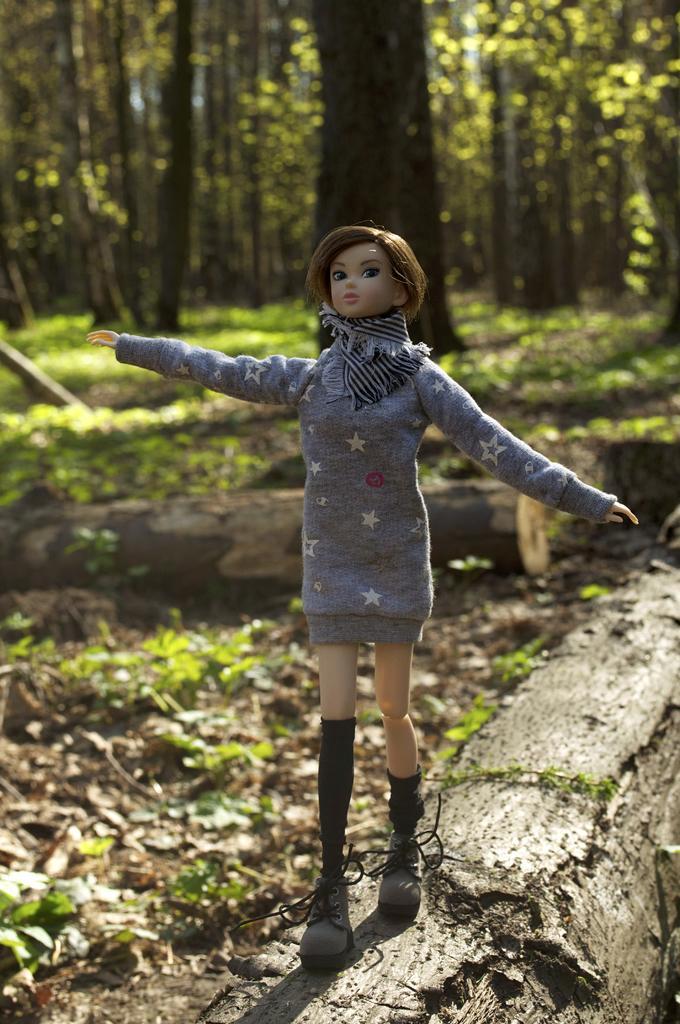Describe this image in one or two sentences. In this image we can see a doll on a wood log. In the background, we can see some wood logs, group of trees and some plants. 